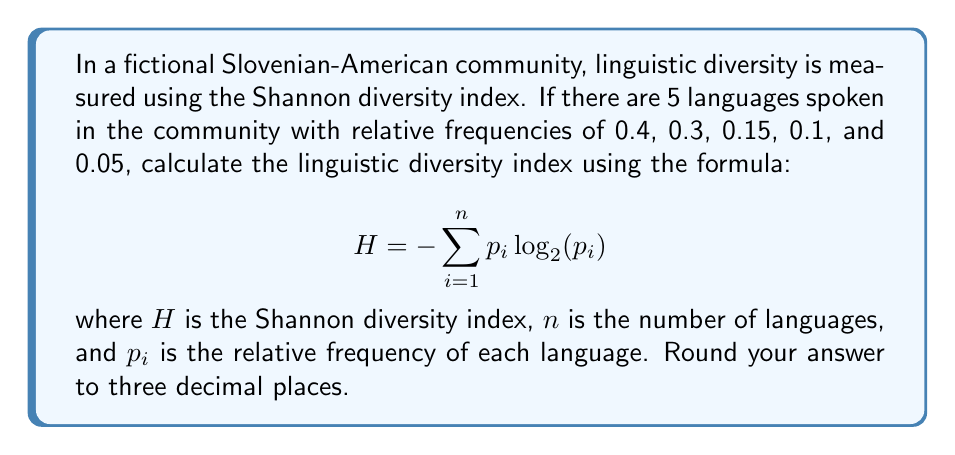What is the answer to this math problem? To calculate the Shannon diversity index, we need to follow these steps:

1. Identify the relative frequencies ($p_i$) for each language:
   $p_1 = 0.4$, $p_2 = 0.3$, $p_3 = 0.15$, $p_4 = 0.1$, $p_5 = 0.05$

2. Calculate $p_i \log_2(p_i)$ for each language:
   
   For $p_1$: $0.4 \log_2(0.4) = 0.4 \times (-1.322) = -0.5288$
   For $p_2$: $0.3 \log_2(0.3) = 0.3 \times (-1.737) = -0.5211$
   For $p_3$: $0.15 \log_2(0.15) = 0.15 \times (-2.737) = -0.4106$
   For $p_4$: $0.1 \log_2(0.1) = 0.1 \times (-3.322) = -0.3322$
   For $p_5$: $0.05 \log_2(0.05) = 0.05 \times (-4.322) = -0.2161$

3. Sum up all the calculated values and multiply by -1:

   $H = -(-0.5288 - 0.5211 - 0.4106 - 0.3322 - 0.2161)$
   
   $H = -(- 2.0088)$
   
   $H = 2.0088$

4. Round the result to three decimal places:

   $H \approx 2.009$

The linguistic diversity index for this Slovenian-American community is approximately 2.009.
Answer: 2.009 